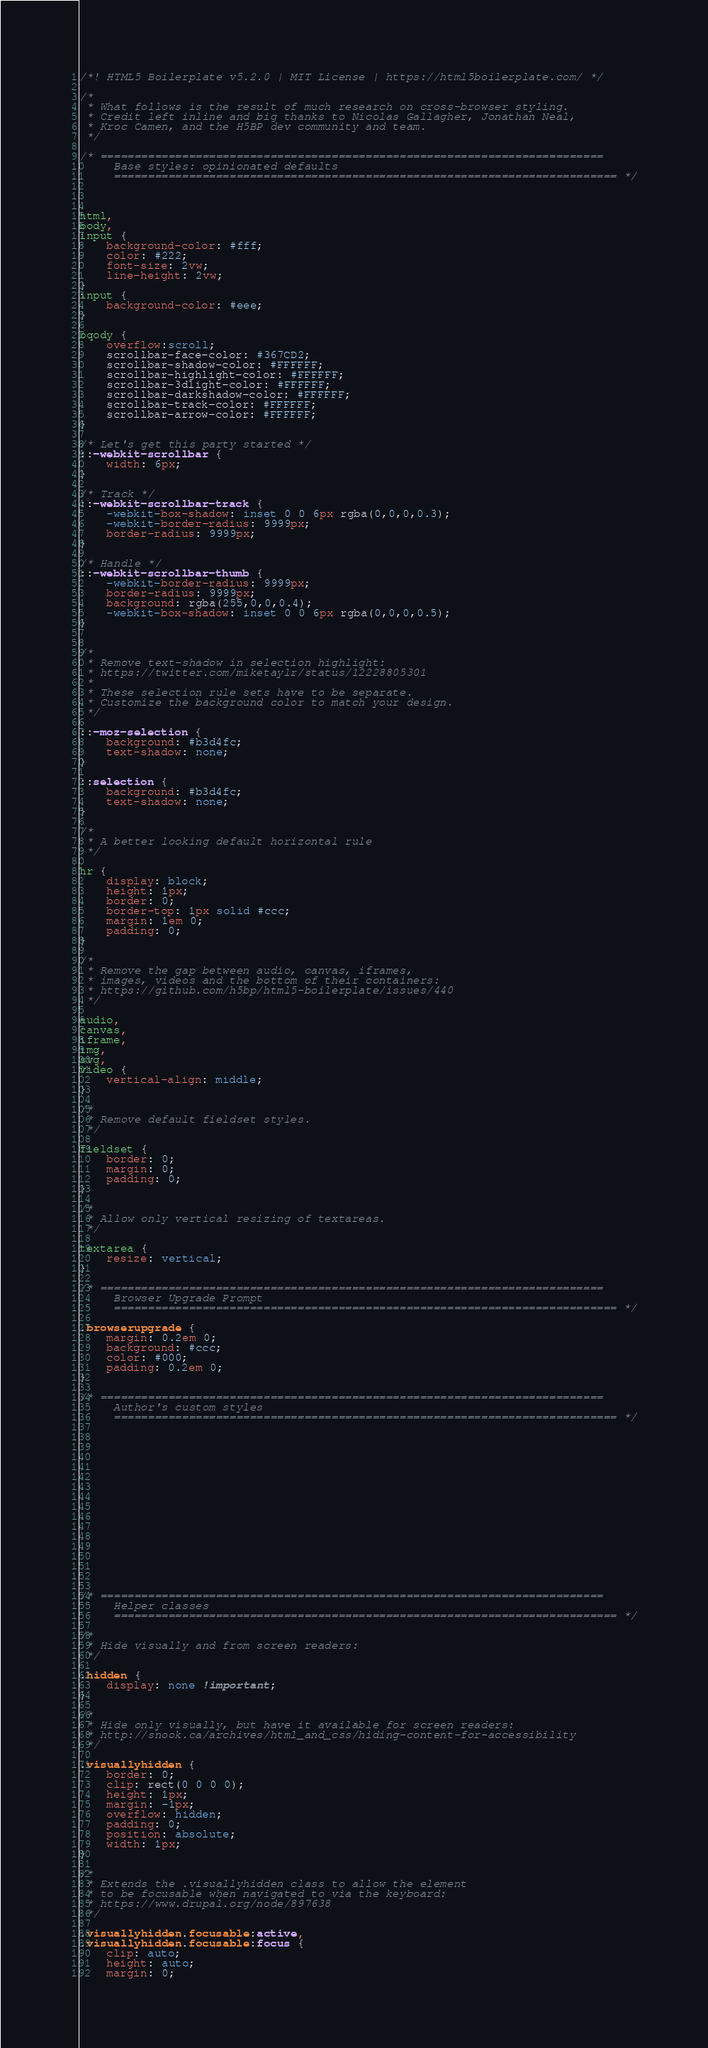<code> <loc_0><loc_0><loc_500><loc_500><_CSS_>/*! HTML5 Boilerplate v5.2.0 | MIT License | https://html5boilerplate.com/ */

/*
 * What follows is the result of much research on cross-browser styling.
 * Credit left inline and big thanks to Nicolas Gallagher, Jonathan Neal,
 * Kroc Camen, and the H5BP dev community and team.
 */

/* ==========================================================================
	 Base styles: opinionated defaults
	 ========================================================================== */

	
	 
html,
body,
input {
	background-color: #fff;
	color: #222;
	font-size: 2vw;
	line-height: 2vw;
}
input {
	background-color: #eee;
}

bqody {
	overflow:scroll;
	scrollbar-face-color: #367CD2;
	scrollbar-shadow-color: #FFFFFF;
	scrollbar-highlight-color: #FFFFFF;
	scrollbar-3dlight-color: #FFFFFF;
	scrollbar-darkshadow-color: #FFFFFF;
	scrollbar-track-color: #FFFFFF;
	scrollbar-arrow-color: #FFFFFF;
}

/* Let's get this party started */
::-webkit-scrollbar {
	width: 6px;
}

/* Track */
::-webkit-scrollbar-track {
	-webkit-box-shadow: inset 0 0 6px rgba(0,0,0,0.3);
	-webkit-border-radius: 9999px;
	border-radius: 9999px;
}

/* Handle */
::-webkit-scrollbar-thumb {
	-webkit-border-radius: 9999px;
	border-radius: 9999px;
	background: rgba(255,0,0,0.4);
	-webkit-box-shadow: inset 0 0 6px rgba(0,0,0,0.5);
}


/*
 * Remove text-shadow in selection highlight:
 * https://twitter.com/miketaylr/status/12228805301
 *
 * These selection rule sets have to be separate.
 * Customize the background color to match your design.
 */

::-moz-selection {
	background: #b3d4fc;
	text-shadow: none;
}

::selection {
	background: #b3d4fc;
	text-shadow: none;
}

/*
 * A better looking default horizontal rule
 */

hr {
	display: block;
	height: 1px;
	border: 0;
	border-top: 1px solid #ccc;
	margin: 1em 0;
	padding: 0;
}

/*
 * Remove the gap between audio, canvas, iframes,
 * images, videos and the bottom of their containers:
 * https://github.com/h5bp/html5-boilerplate/issues/440
 */

audio,
canvas,
iframe,
img,
svg,
video {
	vertical-align: middle;
}

/*
 * Remove default fieldset styles.
 */

fieldset {
	border: 0;
	margin: 0;
	padding: 0;
}

/*
 * Allow only vertical resizing of textareas.
 */

textarea {
	resize: vertical;
}

/* ==========================================================================
	 Browser Upgrade Prompt
	 ========================================================================== */

.browserupgrade {
	margin: 0.2em 0;
	background: #ccc;
	color: #000;
	padding: 0.2em 0;
}

/* ==========================================================================
	 Author's custom styles
	 ========================================================================== */

















/* ==========================================================================
	 Helper classes
	 ========================================================================== */

/*
 * Hide visually and from screen readers:
 */

.hidden {
	display: none !important;
}

/*
 * Hide only visually, but have it available for screen readers:
 * http://snook.ca/archives/html_and_css/hiding-content-for-accessibility
 */

.visuallyhidden {
	border: 0;
	clip: rect(0 0 0 0);
	height: 1px;
	margin: -1px;
	overflow: hidden;
	padding: 0;
	position: absolute;
	width: 1px;
}

/*
 * Extends the .visuallyhidden class to allow the element
 * to be focusable when navigated to via the keyboard:
 * https://www.drupal.org/node/897638
 */

.visuallyhidden.focusable:active,
.visuallyhidden.focusable:focus {
	clip: auto;
	height: auto;
	margin: 0;</code> 